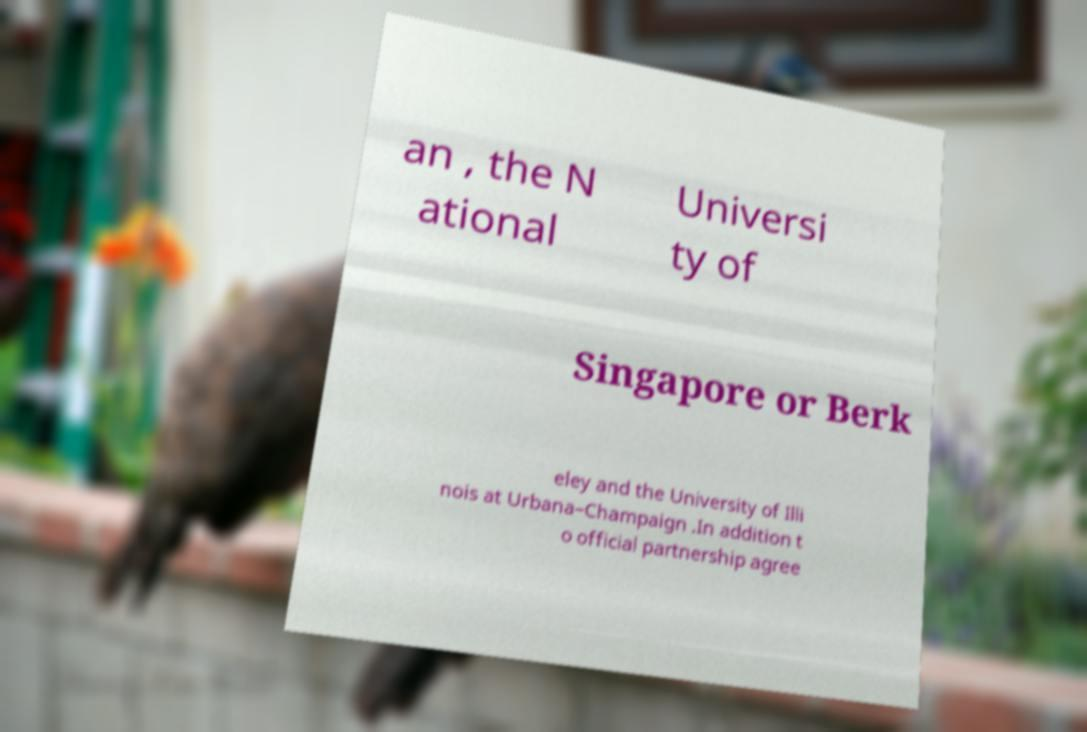Please read and relay the text visible in this image. What does it say? an , the N ational Universi ty of Singapore or Berk eley and the University of Illi nois at Urbana–Champaign .In addition t o official partnership agree 